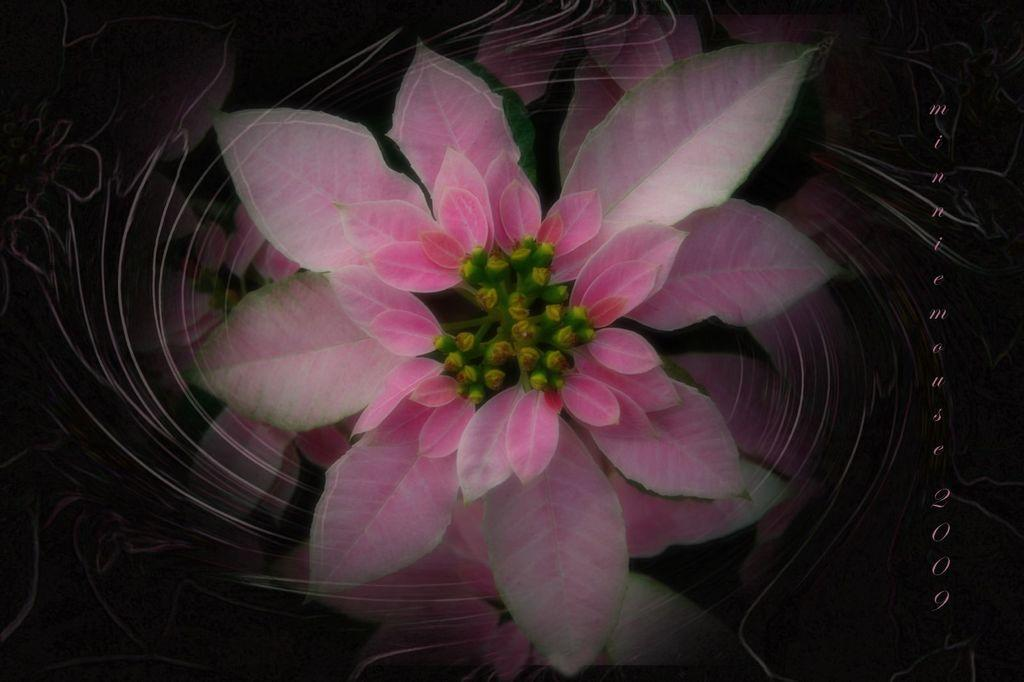What is present in the picture? There is a plant in the picture. Can you describe the plant? The plant is pink in color. What can be observed about the background of the image? The background of the image is dark. Is there any additional element present in the image? Yes, there is a watermark on the right side of the image. What type of roof design can be seen on the plant in the image? There is no roof present in the image, as it features a plant and not a building. 